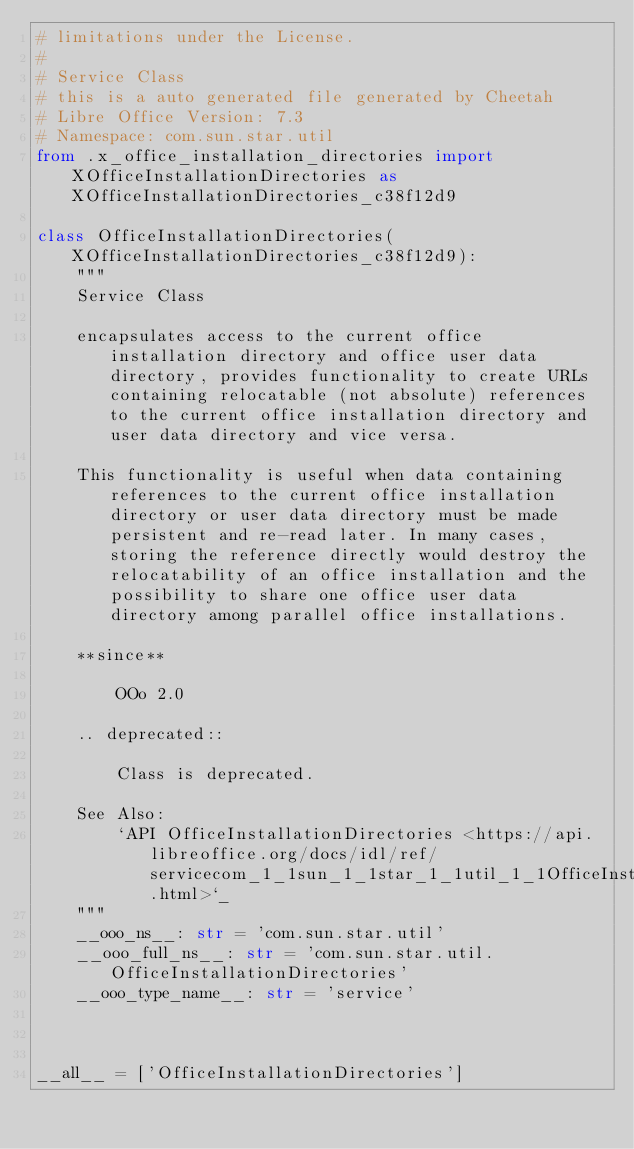<code> <loc_0><loc_0><loc_500><loc_500><_Python_># limitations under the License.
#
# Service Class
# this is a auto generated file generated by Cheetah
# Libre Office Version: 7.3
# Namespace: com.sun.star.util
from .x_office_installation_directories import XOfficeInstallationDirectories as XOfficeInstallationDirectories_c38f12d9

class OfficeInstallationDirectories(XOfficeInstallationDirectories_c38f12d9):
    """
    Service Class

    encapsulates access to the current office installation directory and office user data directory, provides functionality to create URLs containing relocatable (not absolute) references to the current office installation directory and user data directory and vice versa.
    
    This functionality is useful when data containing references to the current office installation directory or user data directory must be made persistent and re-read later. In many cases, storing the reference directly would destroy the relocatability of an office installation and the possibility to share one office user data directory among parallel office installations.
    
    **since**
    
        OOo 2.0
    
    .. deprecated::
    
        Class is deprecated.

    See Also:
        `API OfficeInstallationDirectories <https://api.libreoffice.org/docs/idl/ref/servicecom_1_1sun_1_1star_1_1util_1_1OfficeInstallationDirectories.html>`_
    """
    __ooo_ns__: str = 'com.sun.star.util'
    __ooo_full_ns__: str = 'com.sun.star.util.OfficeInstallationDirectories'
    __ooo_type_name__: str = 'service'



__all__ = ['OfficeInstallationDirectories']

</code> 